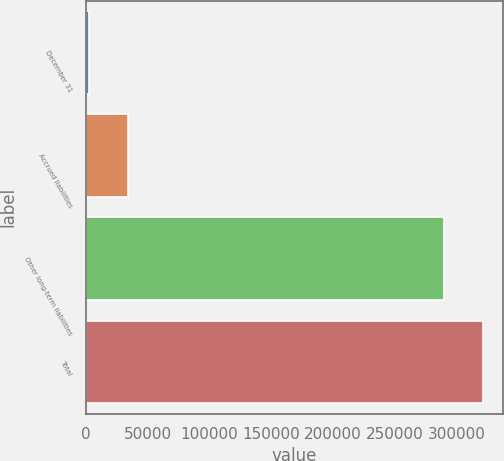<chart> <loc_0><loc_0><loc_500><loc_500><bar_chart><fcel>December 31<fcel>Accrued liabilities<fcel>Other long-term liabilities<fcel>Total<nl><fcel>2011<fcel>33663.5<fcel>289736<fcel>321388<nl></chart> 